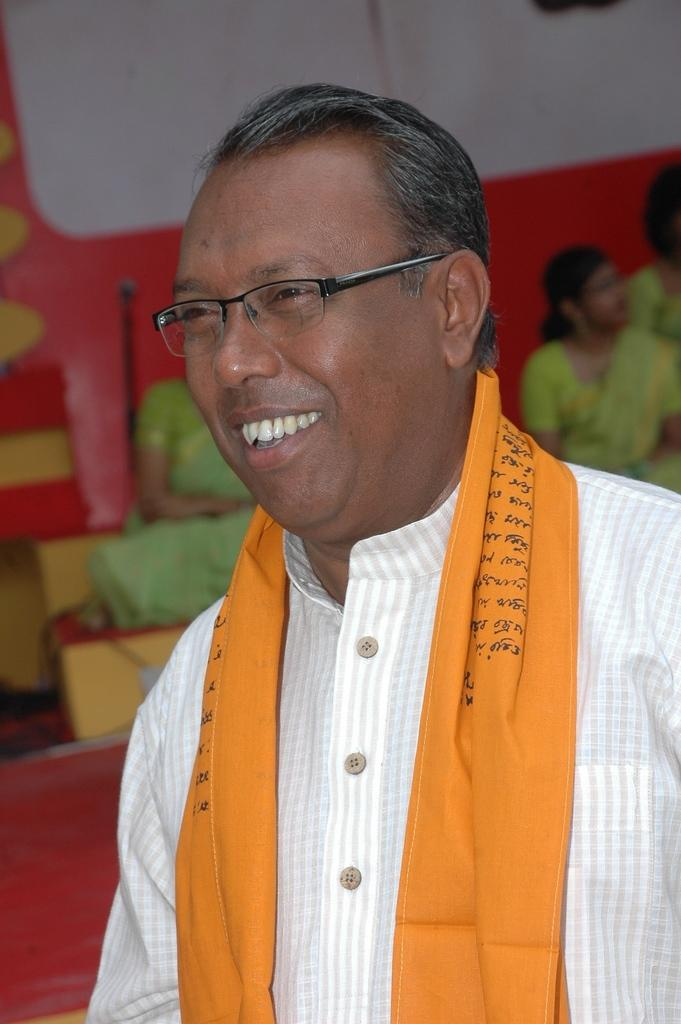What is the main subject of the image? The main subject of the image is a man. Can you describe the man's appearance? The man is wearing clothes and spectacles, and he is smiling. What can be seen in the background of the image? There are women sitting in the background, and they are wearing sarees. How would you describe the background of the image? The background is blurred. What type of box can be seen in the image? There is no box present in the image. What is the weight of the appliance being used by the man in the image? There is no appliance being used by the man in the image. 